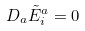Convert formula to latex. <formula><loc_0><loc_0><loc_500><loc_500>D _ { a } \tilde { E } _ { i } ^ { a } = 0</formula> 